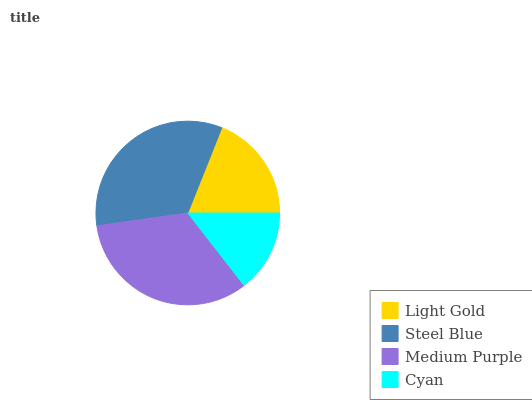Is Cyan the minimum?
Answer yes or no. Yes. Is Medium Purple the maximum?
Answer yes or no. Yes. Is Steel Blue the minimum?
Answer yes or no. No. Is Steel Blue the maximum?
Answer yes or no. No. Is Steel Blue greater than Light Gold?
Answer yes or no. Yes. Is Light Gold less than Steel Blue?
Answer yes or no. Yes. Is Light Gold greater than Steel Blue?
Answer yes or no. No. Is Steel Blue less than Light Gold?
Answer yes or no. No. Is Steel Blue the high median?
Answer yes or no. Yes. Is Light Gold the low median?
Answer yes or no. Yes. Is Cyan the high median?
Answer yes or no. No. Is Steel Blue the low median?
Answer yes or no. No. 